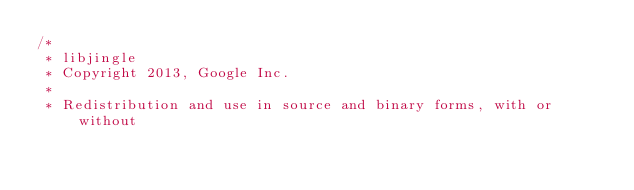Convert code to text. <code><loc_0><loc_0><loc_500><loc_500><_ObjectiveC_>/*
 * libjingle
 * Copyright 2013, Google Inc.
 *
 * Redistribution and use in source and binary forms, with or without</code> 